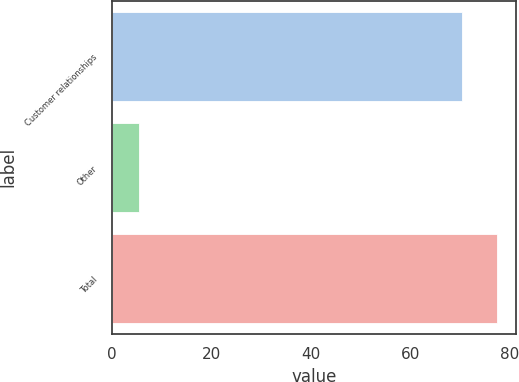<chart> <loc_0><loc_0><loc_500><loc_500><bar_chart><fcel>Customer relationships<fcel>Other<fcel>Total<nl><fcel>70.3<fcel>5.4<fcel>77.33<nl></chart> 